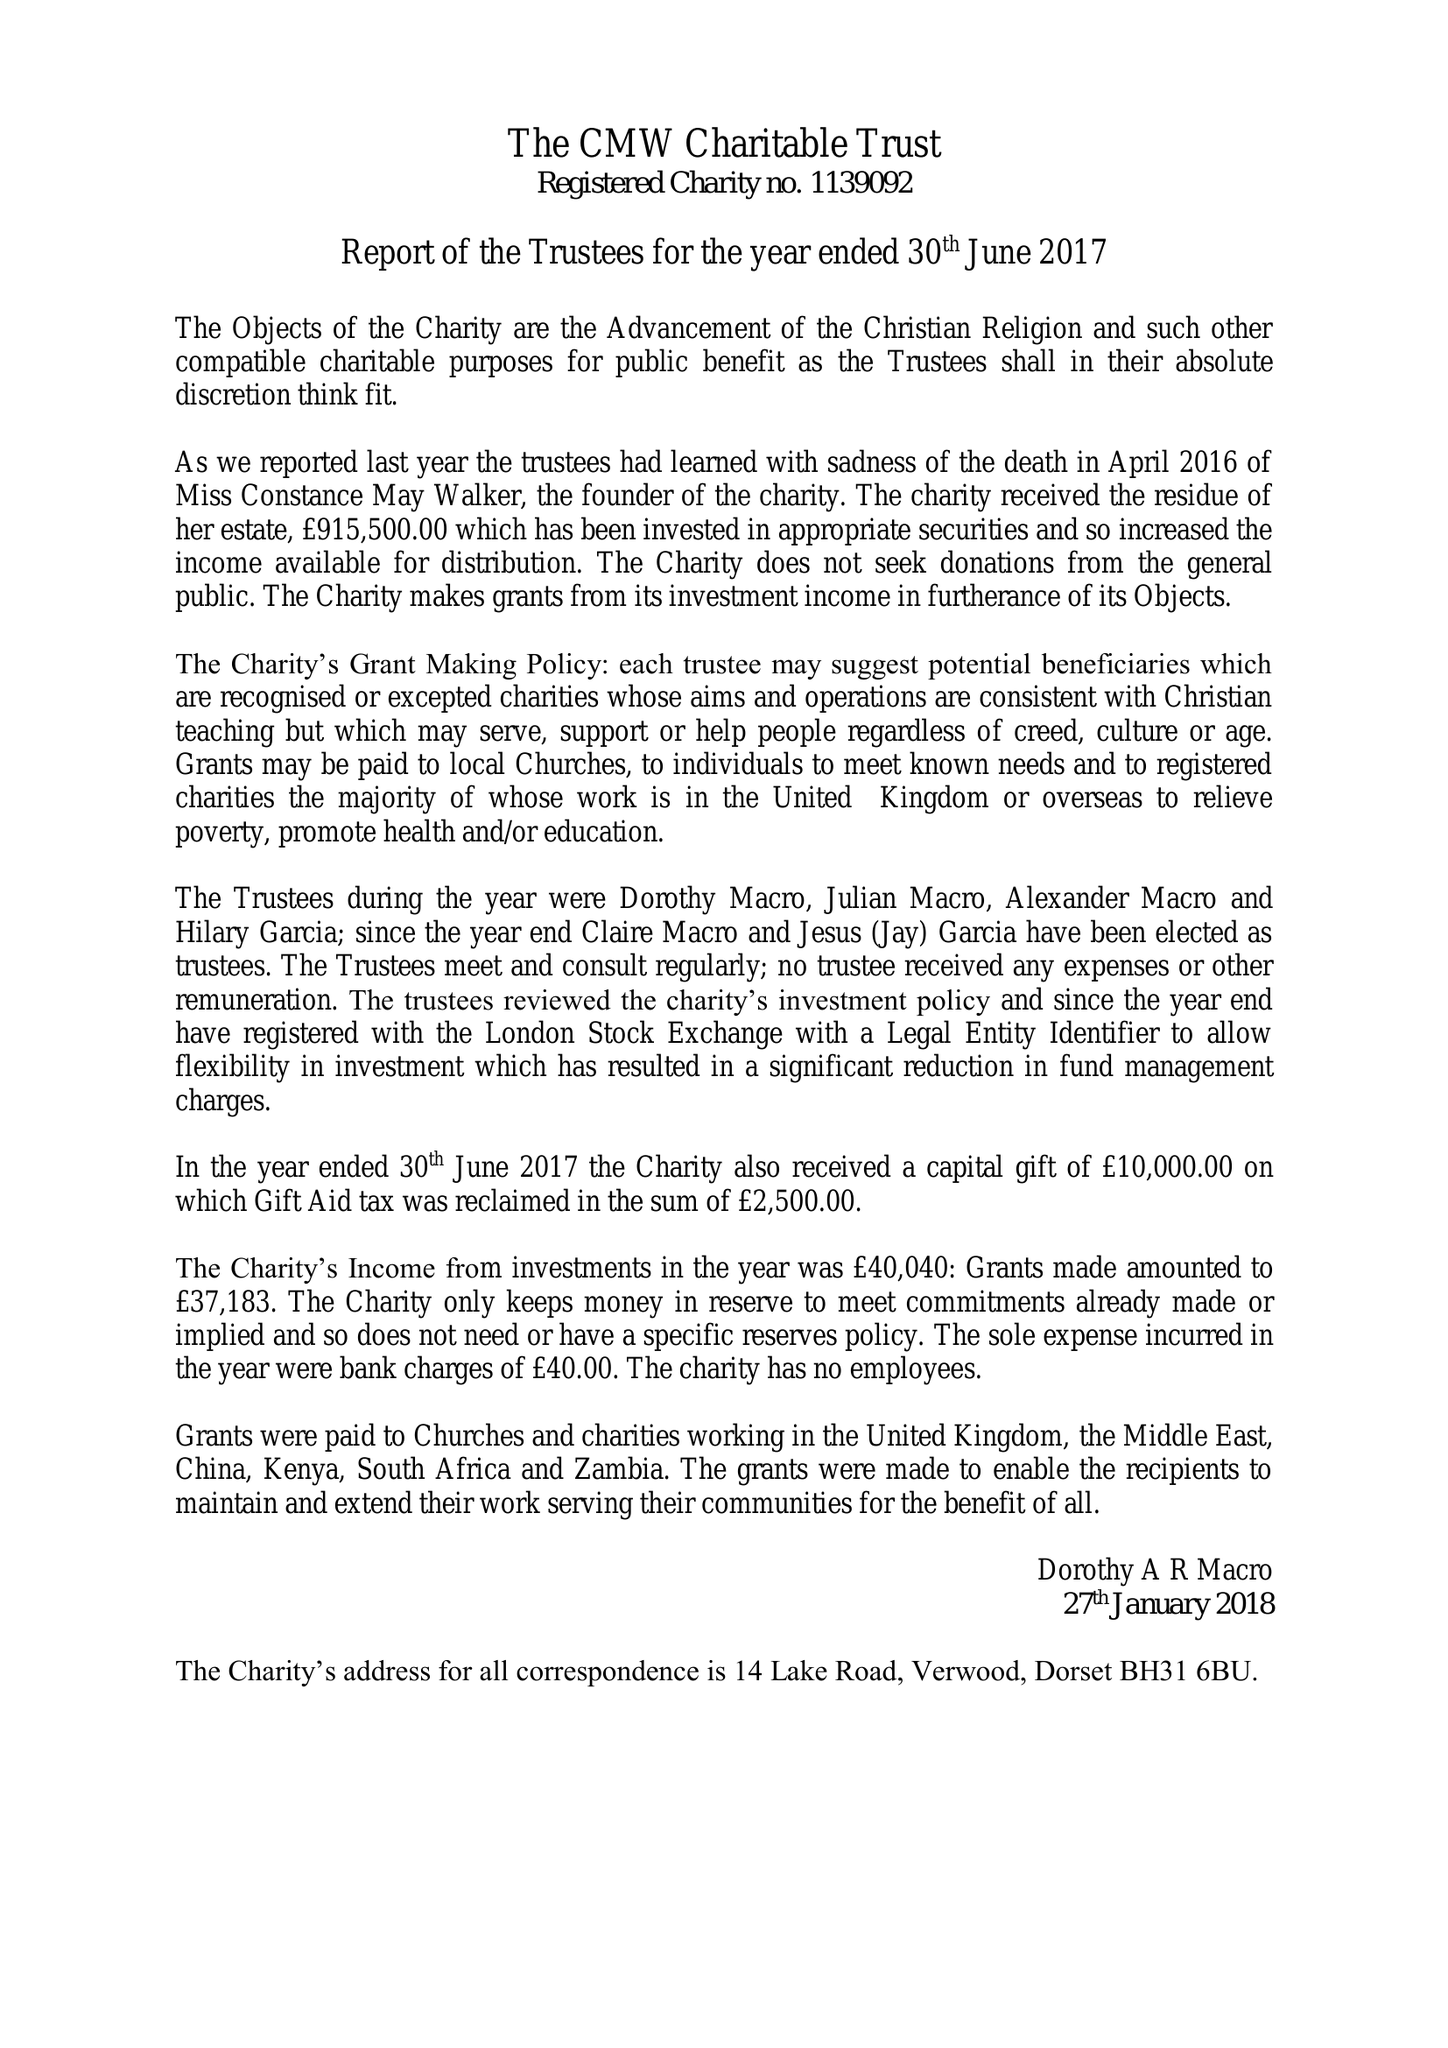What is the value for the spending_annually_in_british_pounds?
Answer the question using a single word or phrase. 37223.00 